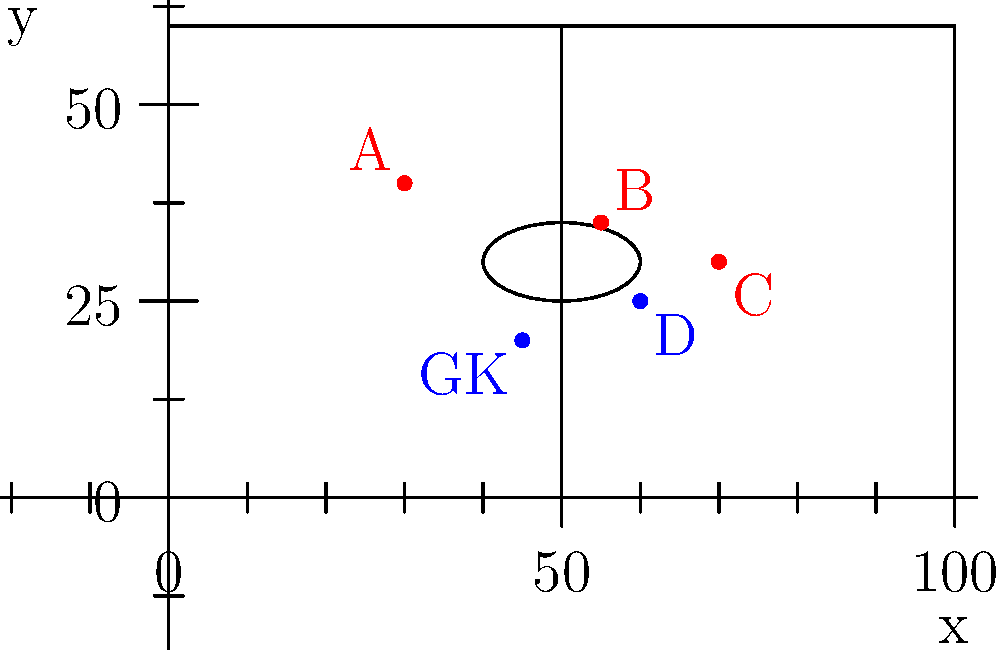In the soccer field represented by the coordinate system above, which attacking player (red) is in an offside position if player D (blue) passes the ball forward? Assume the goalkeeper (GK) is the last defender. To determine if a player is in an offside position, we need to compare their x-coordinate with:
1. The x-coordinate of the ball (player D in this case)
2. The x-coordinate of the second-last defender (GK in this case)

Step 1: Identify the relevant x-coordinates:
- Player A: x ≈ 30
- Player B: x ≈ 55
- Player C: x ≈ 70
- Player D (with the ball): x ≈ 60
- GK (second-last defender): x ≈ 45

Step 2: A player is in an offside position if their x-coordinate is greater than both:
a) The x-coordinate of the ball (60)
b) The x-coordinate of the second-last defender (45)

Step 3: Check each attacking player:
- Player A: 30 < 60 and 30 < 45, so not offside
- Player B: 55 < 60 but 55 > 45, so not offside
- Player C: 70 > 60 and 70 > 45, so offside

Therefore, only Player C is in an offside position.
Answer: Player C 